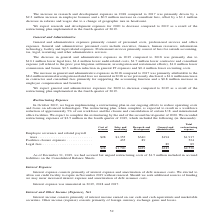From A10 Networks's financial document, What are the three categories of restructuring expenses? The document contains multiple relevant values: Employee severance and related payroll taxes, Facilities closure expenses, Legal fees. From the document: "to 2018 was primarily due to $10.1 million lower legal fees, $1.4 million lower audit-related costs, $1.7 million lower contractor and consultant expe..." Also, What is the change in workforce as a result of the restructuring? reduction of approximately 5%. The document states: "hen complete, is expected to result in a workforce reduction of approximately 5% of our workforce and the closure and consolidation of certain U.S. an..." Also, What is the restructuring costs incurred by the company? According to the financial document, $2,530 (in thousands). The relevant text states: "$28 $1,790 $429 $283 $2,530..." Also, can you calculate: What is the proportion of the cost of revenue and research and development expenses as a percentage of the total restructuring expense? To answer this question, I need to perform calculations using the financial data. The calculation is: ($28 + $429)/$2,530 , which equals 18.06 (percentage). This is based on the information: "$28 $1,790 $429 $283 $2,530 $28 $1,790 $429 $283 $2,530 $28 $1,790 $429 $283 $2,530..." The key data points involved are: 2,530, 28, 429. Also, can you calculate: What is the total legal fees and facilities expenses? Based on the calculation: 89+524, the result is 613 (in thousands). This is based on the information: "$194 $1,917 Facilities closure expenses . 435 89 524 Legal fees. . 89 89 340 $194 $1,917 Facilities closure expenses . 435 89 524 Legal fees. . 89 89..." The key data points involved are: 524, 89. Also, can you calculate: What is the total Sales and marketing and General and administrative? Based on the calculation: 1,790+283, the result is 2073 (in thousands). This is based on the information: "$28 $1,790 $429 $283 $2,530 $28 $1,790 $429 $283 $2,530..." The key data points involved are: 1,790, 283. 